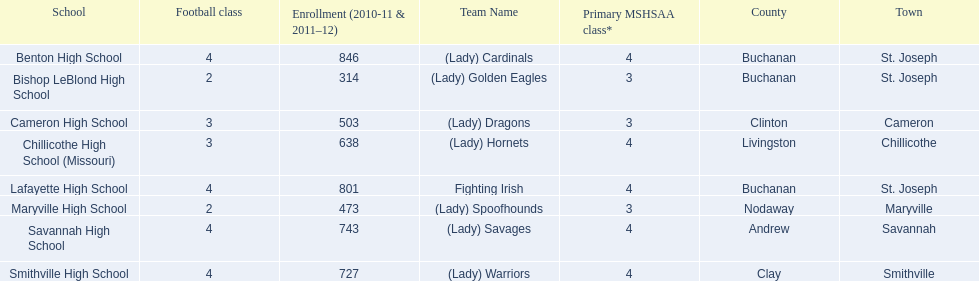What are the three schools in the town of st. joseph? St. Joseph, St. Joseph, St. Joseph. Of the three schools in st. joseph which school's team name does not depict a type of animal? Lafayette High School. 